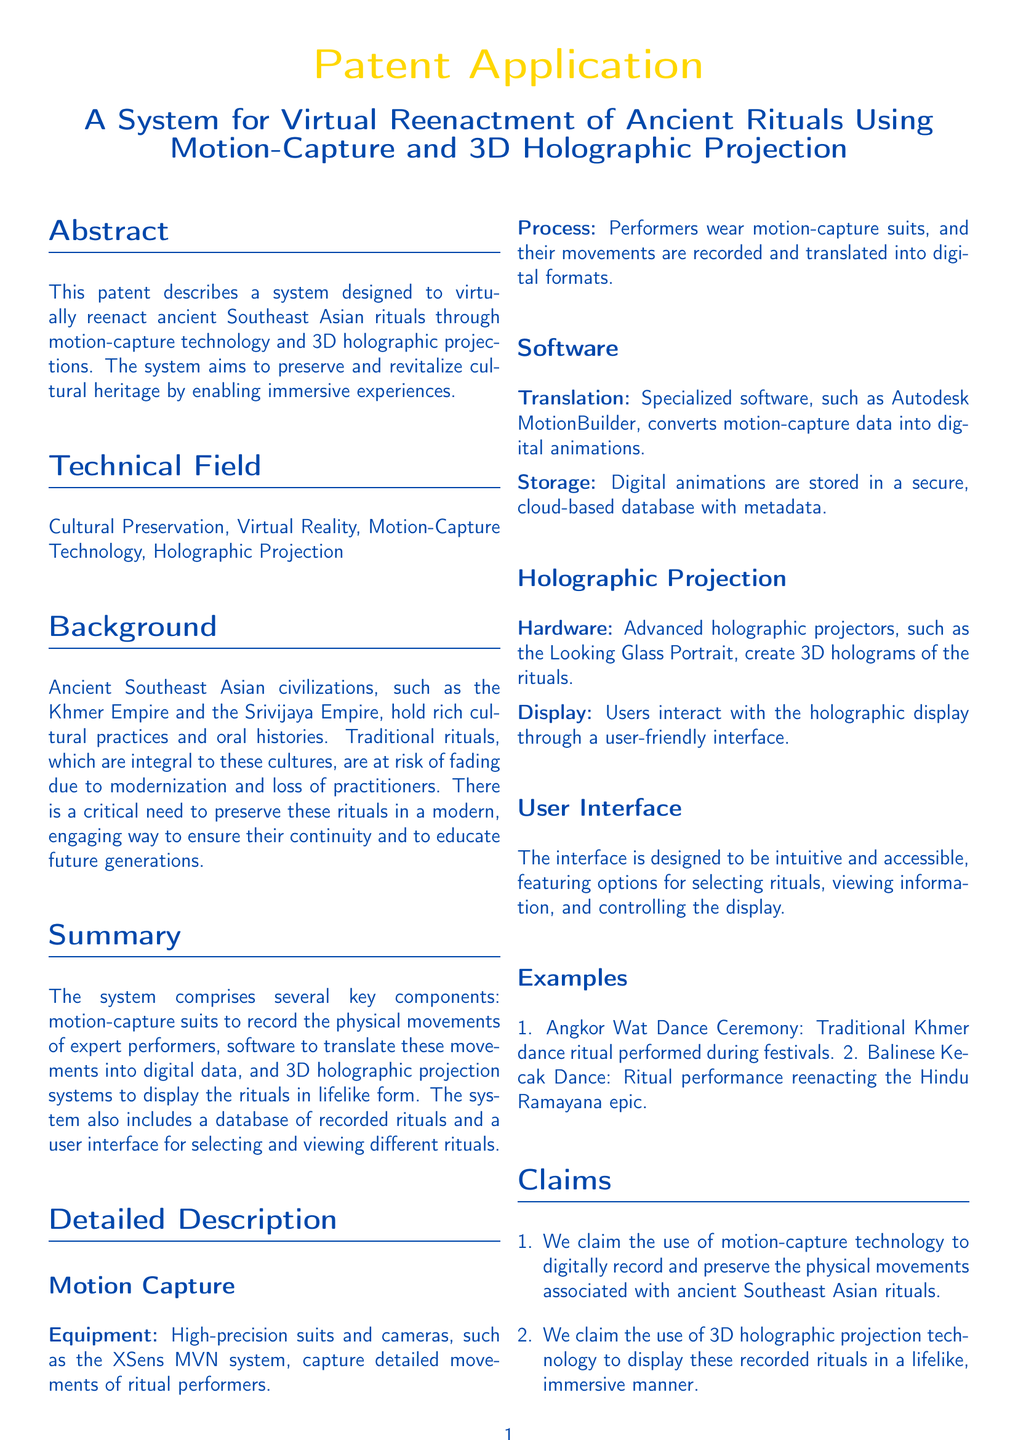What is the patent about? The patent describes a system designed to virtually reenact ancient Southeast Asian rituals through motion-capture technology and 3D holographic projections.
Answer: Virtual reenactment of ancient rituals What technology is used for capturing movements? The document specifies high-precision suits and cameras to capture detailed movements of ritual performers.
Answer: Motion-capture technology Which two ancient Southeast Asian civilizations are mentioned? The document lists the Khmer Empire and the Srivijaya Empire as examples of ancient civilizations with rich cultural practices.
Answer: Khmer Empire, Srivijaya Empire What type of projections does the system utilize? The patent application states that the system uses 3D holographic projections to display the rituals.
Answer: 3D holographic projections How many examples of rituals are provided in the document? The document mentions two examples of rituals in the detailed description section.
Answer: Two What software is mentioned for translating motion-capture data? The document specifies Autodesk MotionBuilder as the software used to convert motion-capture data into digital animations.
Answer: Autodesk MotionBuilder What is the purpose of the database mentioned in the application? The database is intended to hold digital records of various rituals and metadata, which can be accessed through a user-friendly interface.
Answer: Preserve rituals What does the user interface allow users to do? The user interface is designed for selecting rituals, viewing information, and controlling the display.
Answer: Select rituals What is the first claim made in the patent? The first claim pertains to the use of motion-capture technology to digitally record and preserve the physical movements of ancient Southeast Asian rituals.
Answer: Use of motion-capture technology 